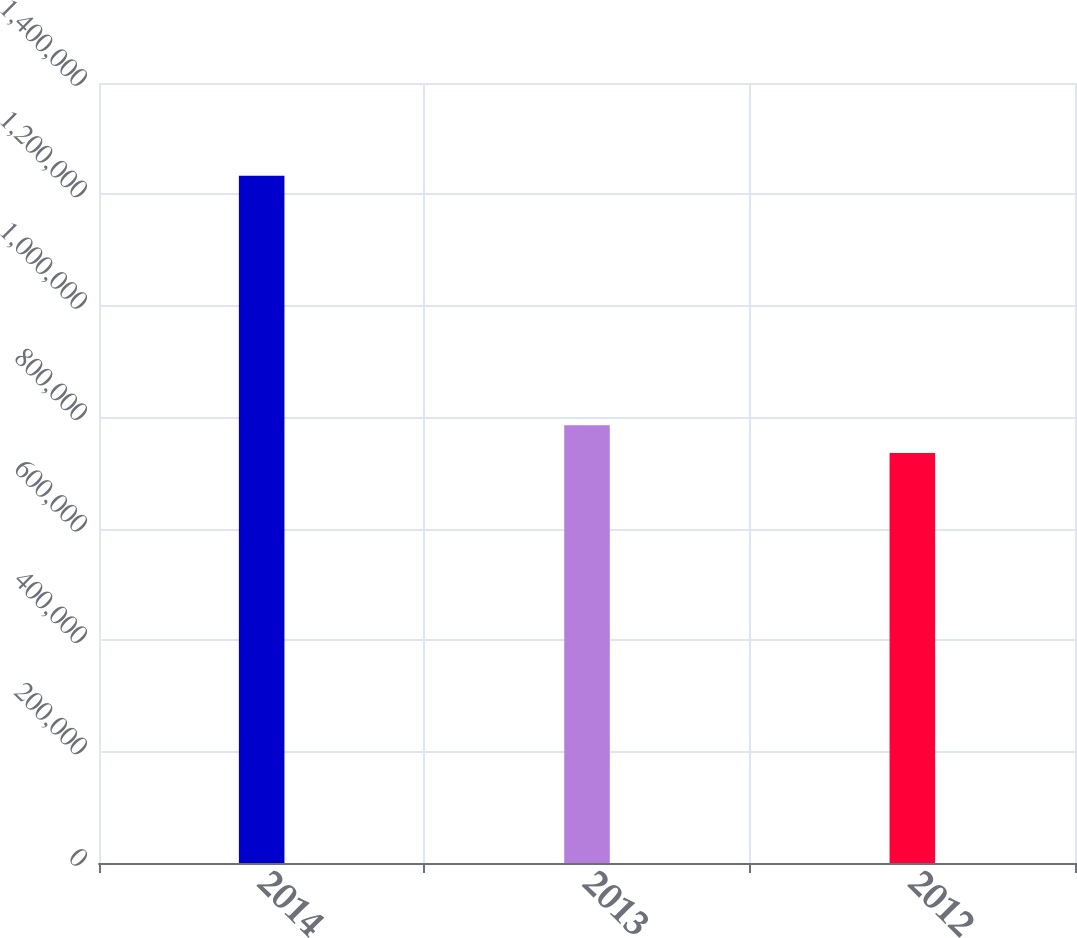Convert chart to OTSL. <chart><loc_0><loc_0><loc_500><loc_500><bar_chart><fcel>2014<fcel>2013<fcel>2012<nl><fcel>1.23339e+06<fcel>785494<fcel>735728<nl></chart> 